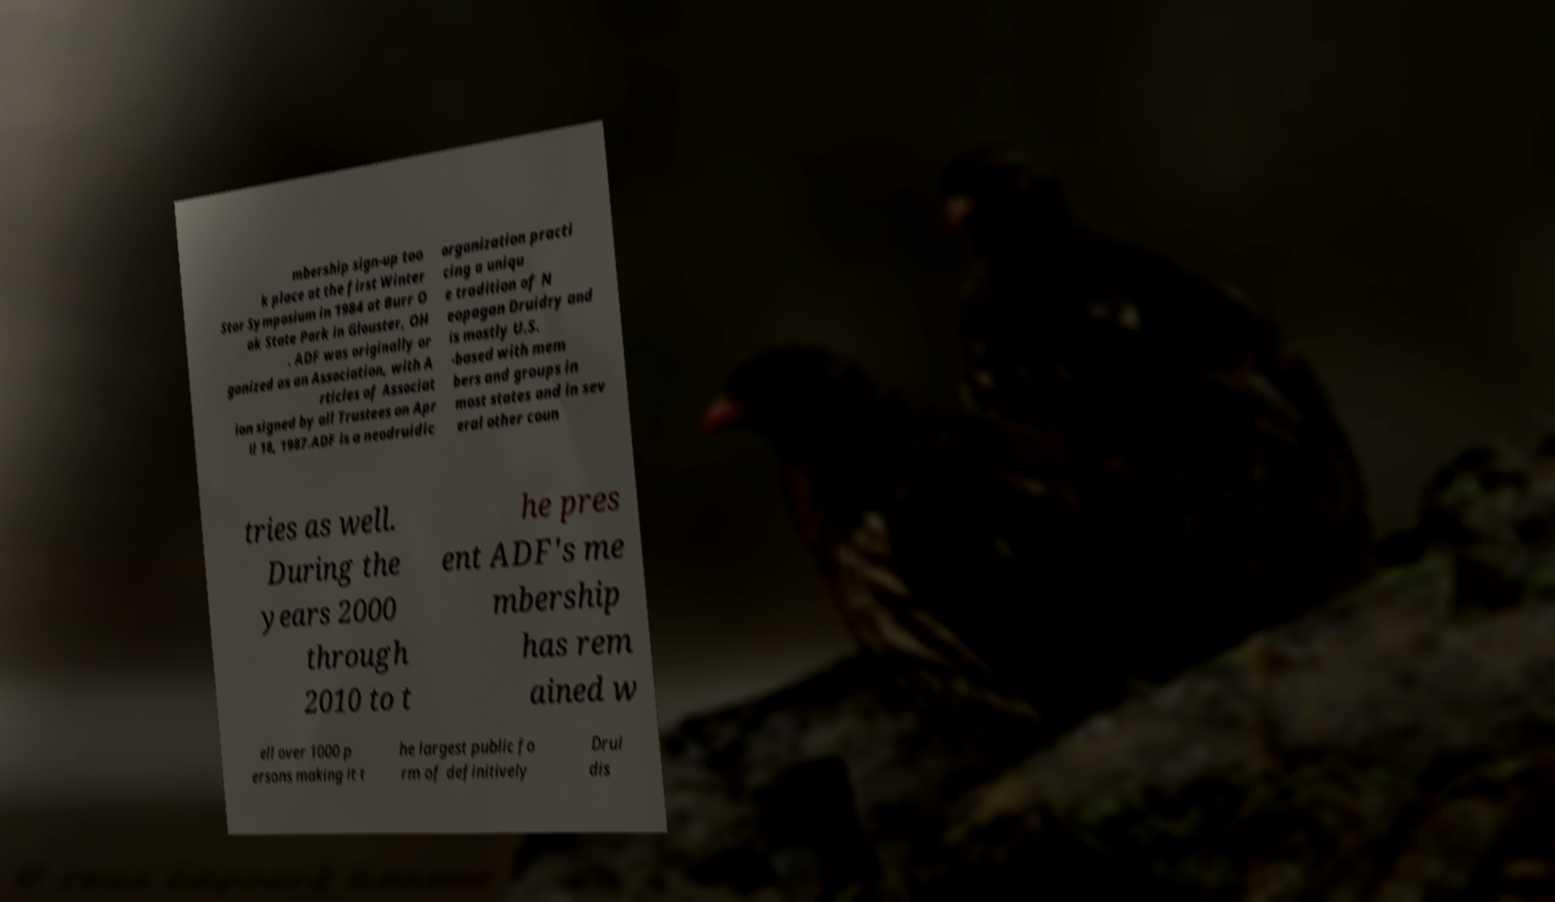Please read and relay the text visible in this image. What does it say? mbership sign-up too k place at the first Winter Star Symposium in 1984 at Burr O ak State Park in Glouster, OH . ADF was originally or ganized as an Association, with A rticles of Associat ion signed by all Trustees on Apr il 18, 1987.ADF is a neodruidic organization practi cing a uniqu e tradition of N eopagan Druidry and is mostly U.S. -based with mem bers and groups in most states and in sev eral other coun tries as well. During the years 2000 through 2010 to t he pres ent ADF's me mbership has rem ained w ell over 1000 p ersons making it t he largest public fo rm of definitively Drui dis 